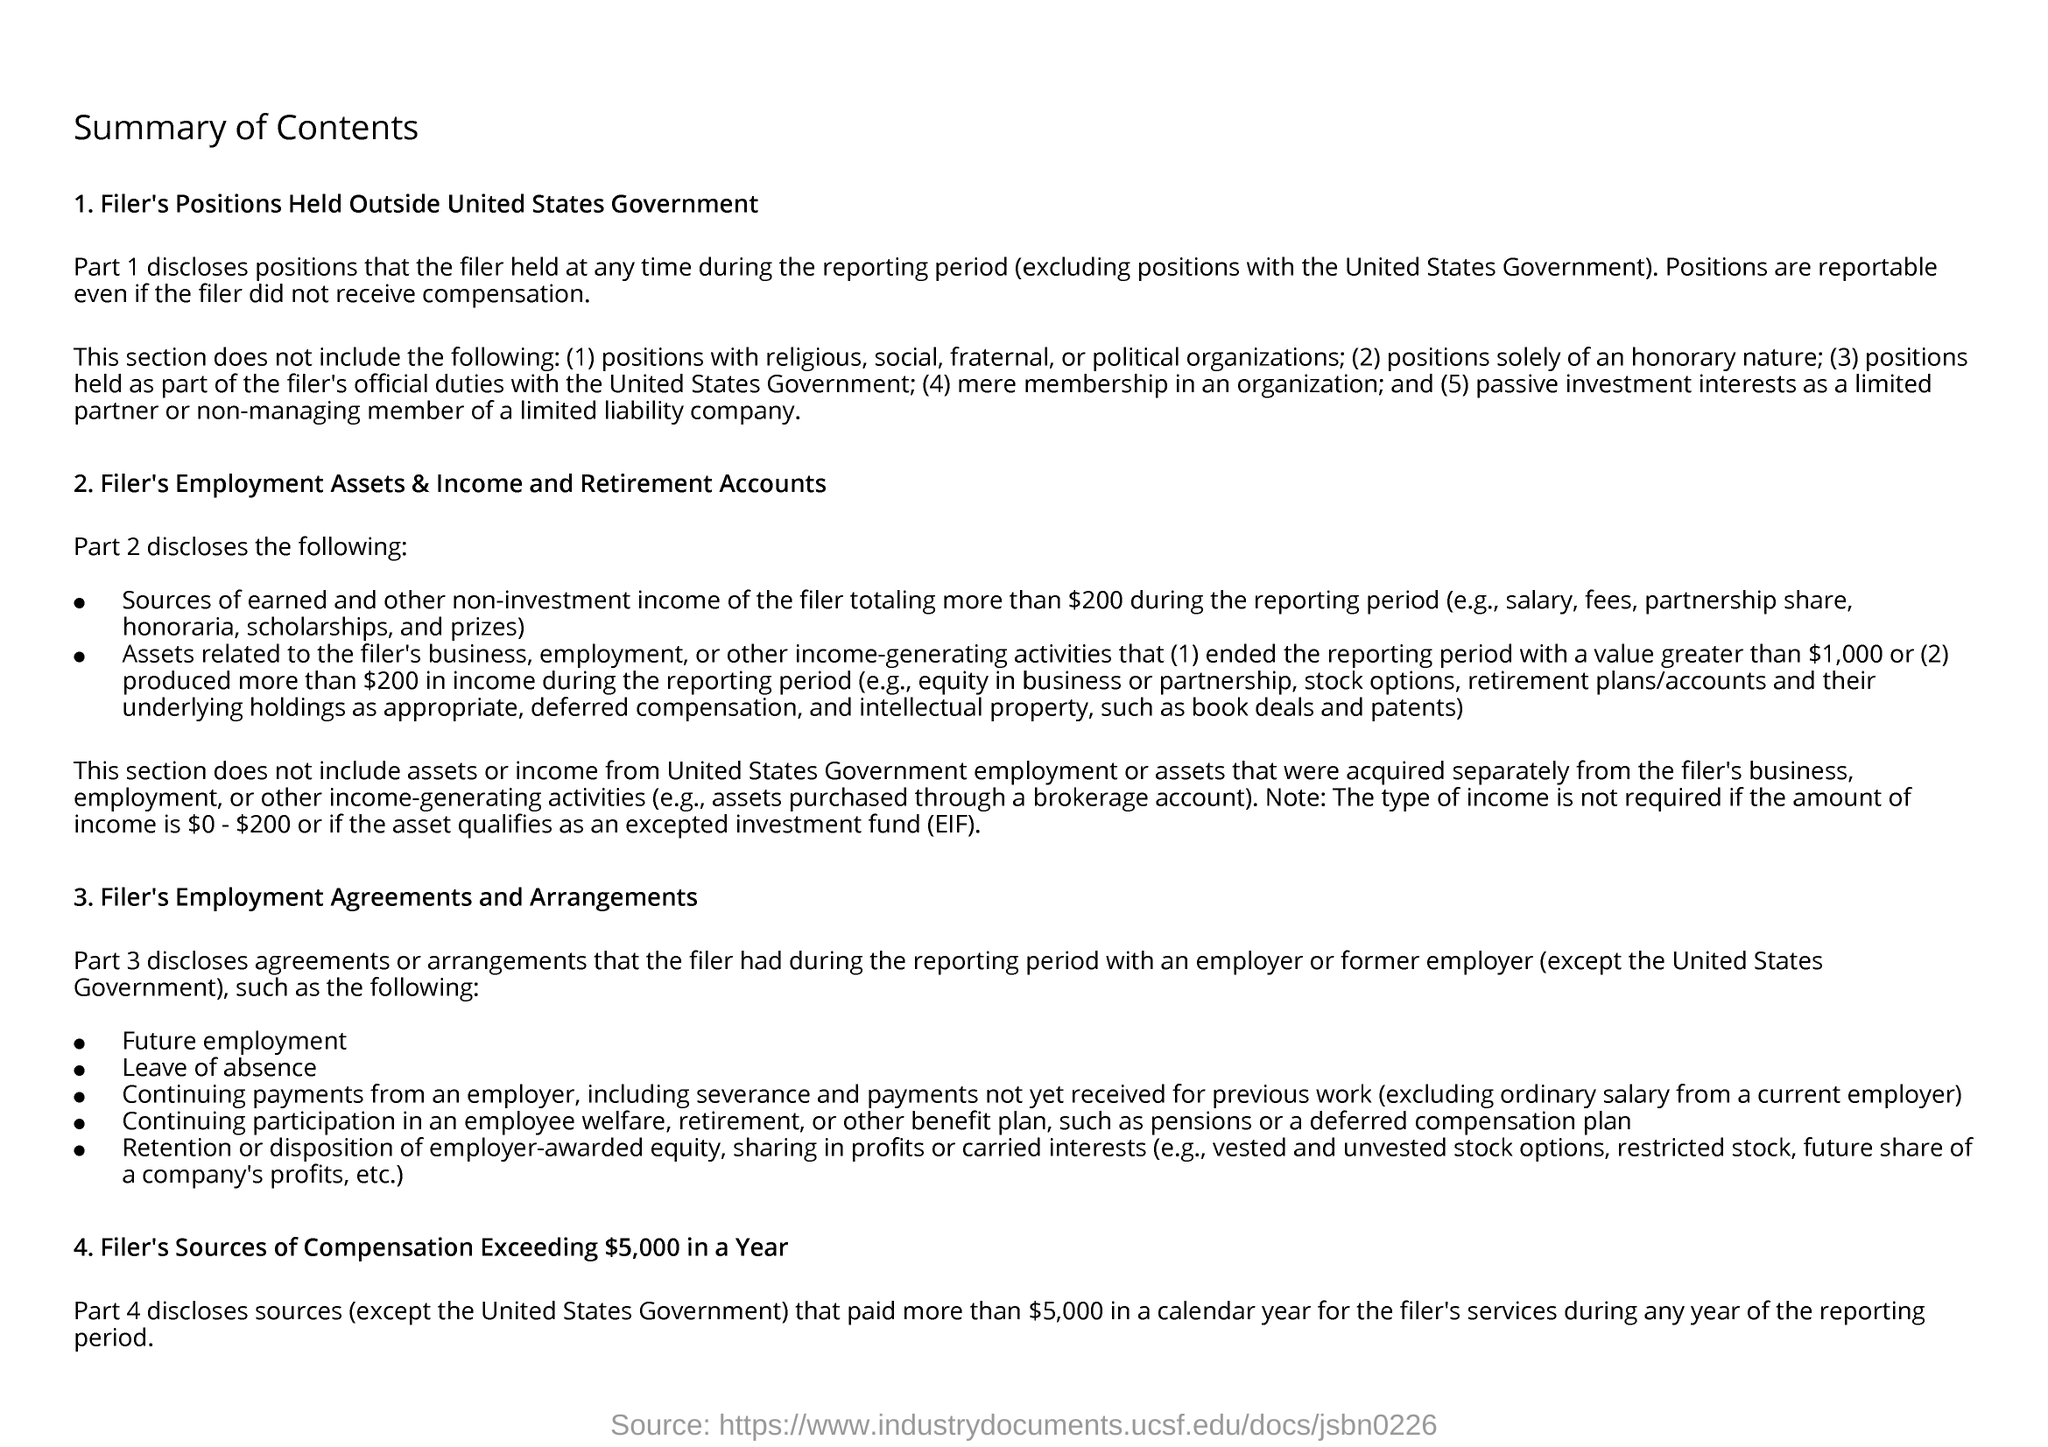Indicate a few pertinent items in this graphic. The filer discloses agreements or arrangements that the filer had during the reporting period with an employer or former employer in Part 3. The filer discloses the positions they held during the reporting period in Part 1 of the form. EXCEPTED INVESTMENT FUND" stands for "Excepted Investment Fund". 